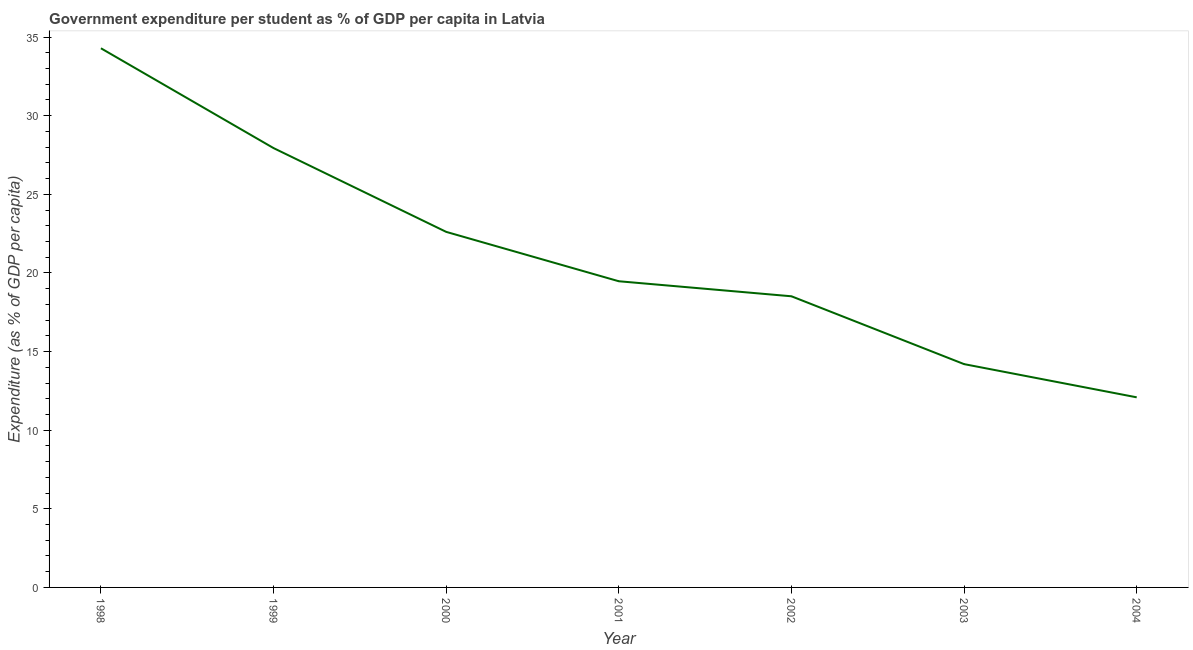What is the government expenditure per student in 2003?
Keep it short and to the point. 14.2. Across all years, what is the maximum government expenditure per student?
Provide a short and direct response. 34.29. Across all years, what is the minimum government expenditure per student?
Ensure brevity in your answer.  12.09. In which year was the government expenditure per student maximum?
Offer a very short reply. 1998. What is the sum of the government expenditure per student?
Offer a terse response. 149.13. What is the difference between the government expenditure per student in 1999 and 2002?
Your response must be concise. 9.43. What is the average government expenditure per student per year?
Your response must be concise. 21.3. What is the median government expenditure per student?
Ensure brevity in your answer.  19.47. In how many years, is the government expenditure per student greater than 21 %?
Ensure brevity in your answer.  3. What is the ratio of the government expenditure per student in 2001 to that in 2003?
Offer a terse response. 1.37. What is the difference between the highest and the second highest government expenditure per student?
Your answer should be compact. 6.35. Is the sum of the government expenditure per student in 2000 and 2004 greater than the maximum government expenditure per student across all years?
Your answer should be very brief. Yes. What is the difference between the highest and the lowest government expenditure per student?
Offer a very short reply. 22.2. Does the government expenditure per student monotonically increase over the years?
Make the answer very short. No. How many lines are there?
Provide a short and direct response. 1. How many years are there in the graph?
Your answer should be very brief. 7. Are the values on the major ticks of Y-axis written in scientific E-notation?
Provide a succinct answer. No. What is the title of the graph?
Your response must be concise. Government expenditure per student as % of GDP per capita in Latvia. What is the label or title of the Y-axis?
Give a very brief answer. Expenditure (as % of GDP per capita). What is the Expenditure (as % of GDP per capita) of 1998?
Your response must be concise. 34.29. What is the Expenditure (as % of GDP per capita) of 1999?
Ensure brevity in your answer.  27.94. What is the Expenditure (as % of GDP per capita) in 2000?
Offer a very short reply. 22.61. What is the Expenditure (as % of GDP per capita) in 2001?
Your answer should be compact. 19.47. What is the Expenditure (as % of GDP per capita) of 2002?
Give a very brief answer. 18.52. What is the Expenditure (as % of GDP per capita) in 2003?
Provide a succinct answer. 14.2. What is the Expenditure (as % of GDP per capita) in 2004?
Give a very brief answer. 12.09. What is the difference between the Expenditure (as % of GDP per capita) in 1998 and 1999?
Provide a short and direct response. 6.35. What is the difference between the Expenditure (as % of GDP per capita) in 1998 and 2000?
Provide a short and direct response. 11.68. What is the difference between the Expenditure (as % of GDP per capita) in 1998 and 2001?
Your answer should be very brief. 14.82. What is the difference between the Expenditure (as % of GDP per capita) in 1998 and 2002?
Provide a succinct answer. 15.77. What is the difference between the Expenditure (as % of GDP per capita) in 1998 and 2003?
Your answer should be very brief. 20.09. What is the difference between the Expenditure (as % of GDP per capita) in 1998 and 2004?
Keep it short and to the point. 22.2. What is the difference between the Expenditure (as % of GDP per capita) in 1999 and 2000?
Make the answer very short. 5.33. What is the difference between the Expenditure (as % of GDP per capita) in 1999 and 2001?
Keep it short and to the point. 8.47. What is the difference between the Expenditure (as % of GDP per capita) in 1999 and 2002?
Give a very brief answer. 9.43. What is the difference between the Expenditure (as % of GDP per capita) in 1999 and 2003?
Your response must be concise. 13.74. What is the difference between the Expenditure (as % of GDP per capita) in 1999 and 2004?
Make the answer very short. 15.85. What is the difference between the Expenditure (as % of GDP per capita) in 2000 and 2001?
Your answer should be very brief. 3.14. What is the difference between the Expenditure (as % of GDP per capita) in 2000 and 2002?
Provide a succinct answer. 4.1. What is the difference between the Expenditure (as % of GDP per capita) in 2000 and 2003?
Offer a very short reply. 8.41. What is the difference between the Expenditure (as % of GDP per capita) in 2000 and 2004?
Give a very brief answer. 10.52. What is the difference between the Expenditure (as % of GDP per capita) in 2001 and 2002?
Your answer should be very brief. 0.96. What is the difference between the Expenditure (as % of GDP per capita) in 2001 and 2003?
Provide a succinct answer. 5.27. What is the difference between the Expenditure (as % of GDP per capita) in 2001 and 2004?
Your answer should be very brief. 7.38. What is the difference between the Expenditure (as % of GDP per capita) in 2002 and 2003?
Your response must be concise. 4.31. What is the difference between the Expenditure (as % of GDP per capita) in 2002 and 2004?
Make the answer very short. 6.43. What is the difference between the Expenditure (as % of GDP per capita) in 2003 and 2004?
Offer a terse response. 2.11. What is the ratio of the Expenditure (as % of GDP per capita) in 1998 to that in 1999?
Keep it short and to the point. 1.23. What is the ratio of the Expenditure (as % of GDP per capita) in 1998 to that in 2000?
Your answer should be compact. 1.52. What is the ratio of the Expenditure (as % of GDP per capita) in 1998 to that in 2001?
Ensure brevity in your answer.  1.76. What is the ratio of the Expenditure (as % of GDP per capita) in 1998 to that in 2002?
Provide a succinct answer. 1.85. What is the ratio of the Expenditure (as % of GDP per capita) in 1998 to that in 2003?
Offer a terse response. 2.41. What is the ratio of the Expenditure (as % of GDP per capita) in 1998 to that in 2004?
Give a very brief answer. 2.84. What is the ratio of the Expenditure (as % of GDP per capita) in 1999 to that in 2000?
Ensure brevity in your answer.  1.24. What is the ratio of the Expenditure (as % of GDP per capita) in 1999 to that in 2001?
Make the answer very short. 1.44. What is the ratio of the Expenditure (as % of GDP per capita) in 1999 to that in 2002?
Your response must be concise. 1.51. What is the ratio of the Expenditure (as % of GDP per capita) in 1999 to that in 2003?
Ensure brevity in your answer.  1.97. What is the ratio of the Expenditure (as % of GDP per capita) in 1999 to that in 2004?
Provide a short and direct response. 2.31. What is the ratio of the Expenditure (as % of GDP per capita) in 2000 to that in 2001?
Your answer should be very brief. 1.16. What is the ratio of the Expenditure (as % of GDP per capita) in 2000 to that in 2002?
Offer a very short reply. 1.22. What is the ratio of the Expenditure (as % of GDP per capita) in 2000 to that in 2003?
Your answer should be very brief. 1.59. What is the ratio of the Expenditure (as % of GDP per capita) in 2000 to that in 2004?
Keep it short and to the point. 1.87. What is the ratio of the Expenditure (as % of GDP per capita) in 2001 to that in 2002?
Your response must be concise. 1.05. What is the ratio of the Expenditure (as % of GDP per capita) in 2001 to that in 2003?
Ensure brevity in your answer.  1.37. What is the ratio of the Expenditure (as % of GDP per capita) in 2001 to that in 2004?
Your response must be concise. 1.61. What is the ratio of the Expenditure (as % of GDP per capita) in 2002 to that in 2003?
Make the answer very short. 1.3. What is the ratio of the Expenditure (as % of GDP per capita) in 2002 to that in 2004?
Your answer should be very brief. 1.53. What is the ratio of the Expenditure (as % of GDP per capita) in 2003 to that in 2004?
Your answer should be compact. 1.18. 